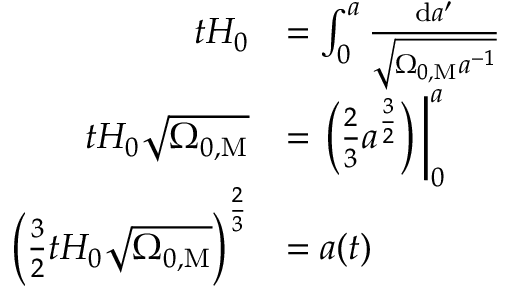Convert formula to latex. <formula><loc_0><loc_0><loc_500><loc_500>{ \begin{array} { r l } { t H _ { 0 } } & { = \int _ { 0 } ^ { a } { \frac { d a ^ { \prime } } { \sqrt { \Omega _ { 0 , M } a ^ { - 1 } } } } } \\ { t H _ { 0 } { \sqrt { \Omega _ { 0 , M } } } } & { = \left ( { \frac { 2 } { 3 } } a ^ { \frac { 3 } { 2 } } \right ) \, \right | _ { 0 } ^ { a } } \\ { \left ( { \frac { 3 } { 2 } } t H _ { 0 } { \sqrt { \Omega _ { 0 , M } } } \right ) ^ { \frac { 2 } { 3 } } } & { = a ( t ) } \end{array} }</formula> 